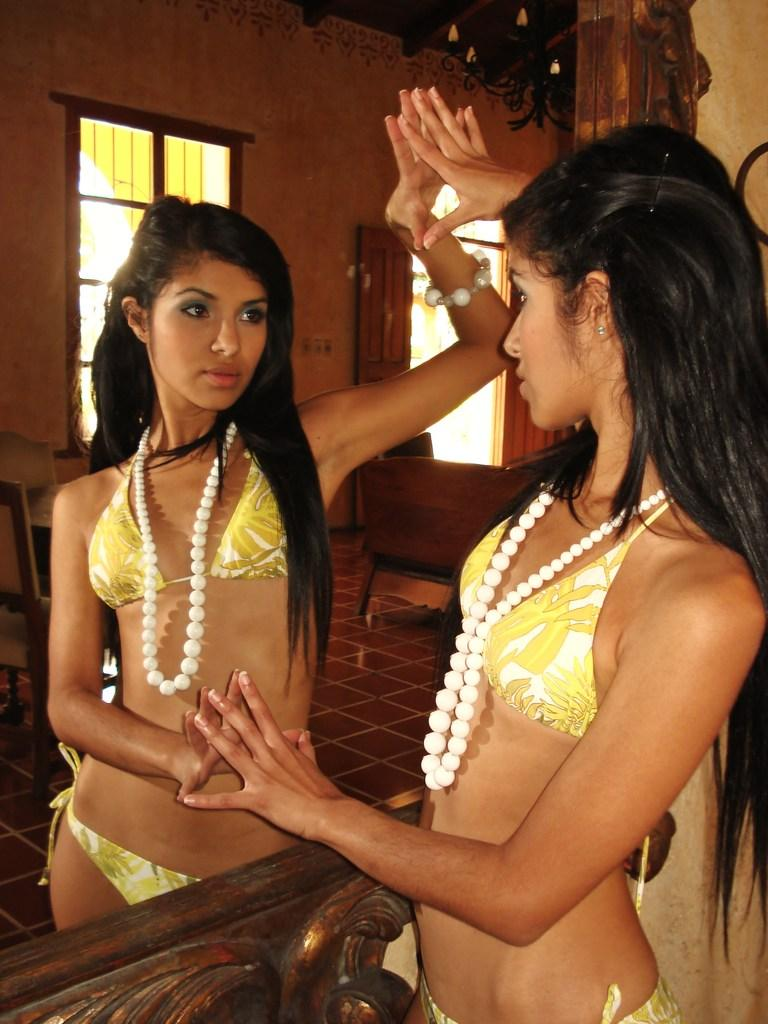Who is present in the image? There is a lady in the image. What object is present in the image that can show reflections? There is a mirror in the image. What can be seen in the mirror's reflection besides the lady? The reflection of the ground, chairs, a window, doors, and lights are visible in the mirror. What type of art can be seen hanging on the wall in the image? There is no art visible on the wall in the image; the focus is on the lady and the mirror's reflections. 